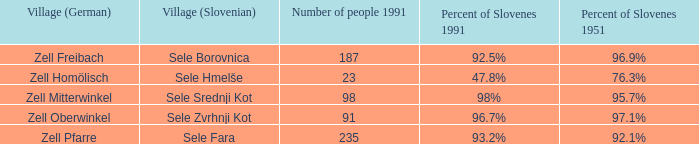Provide me with the name of all the village (German) that are part of the village (Slovenian) with sele borovnica. Zell Freibach. 